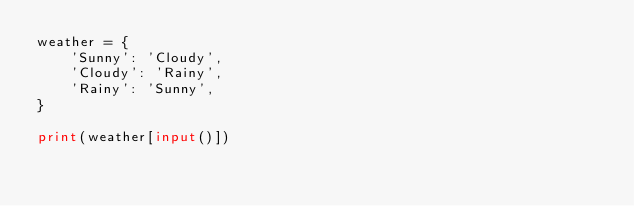<code> <loc_0><loc_0><loc_500><loc_500><_Python_>weather = {
    'Sunny': 'Cloudy',
    'Cloudy': 'Rainy',
    'Rainy': 'Sunny',
}

print(weather[input()])
</code> 